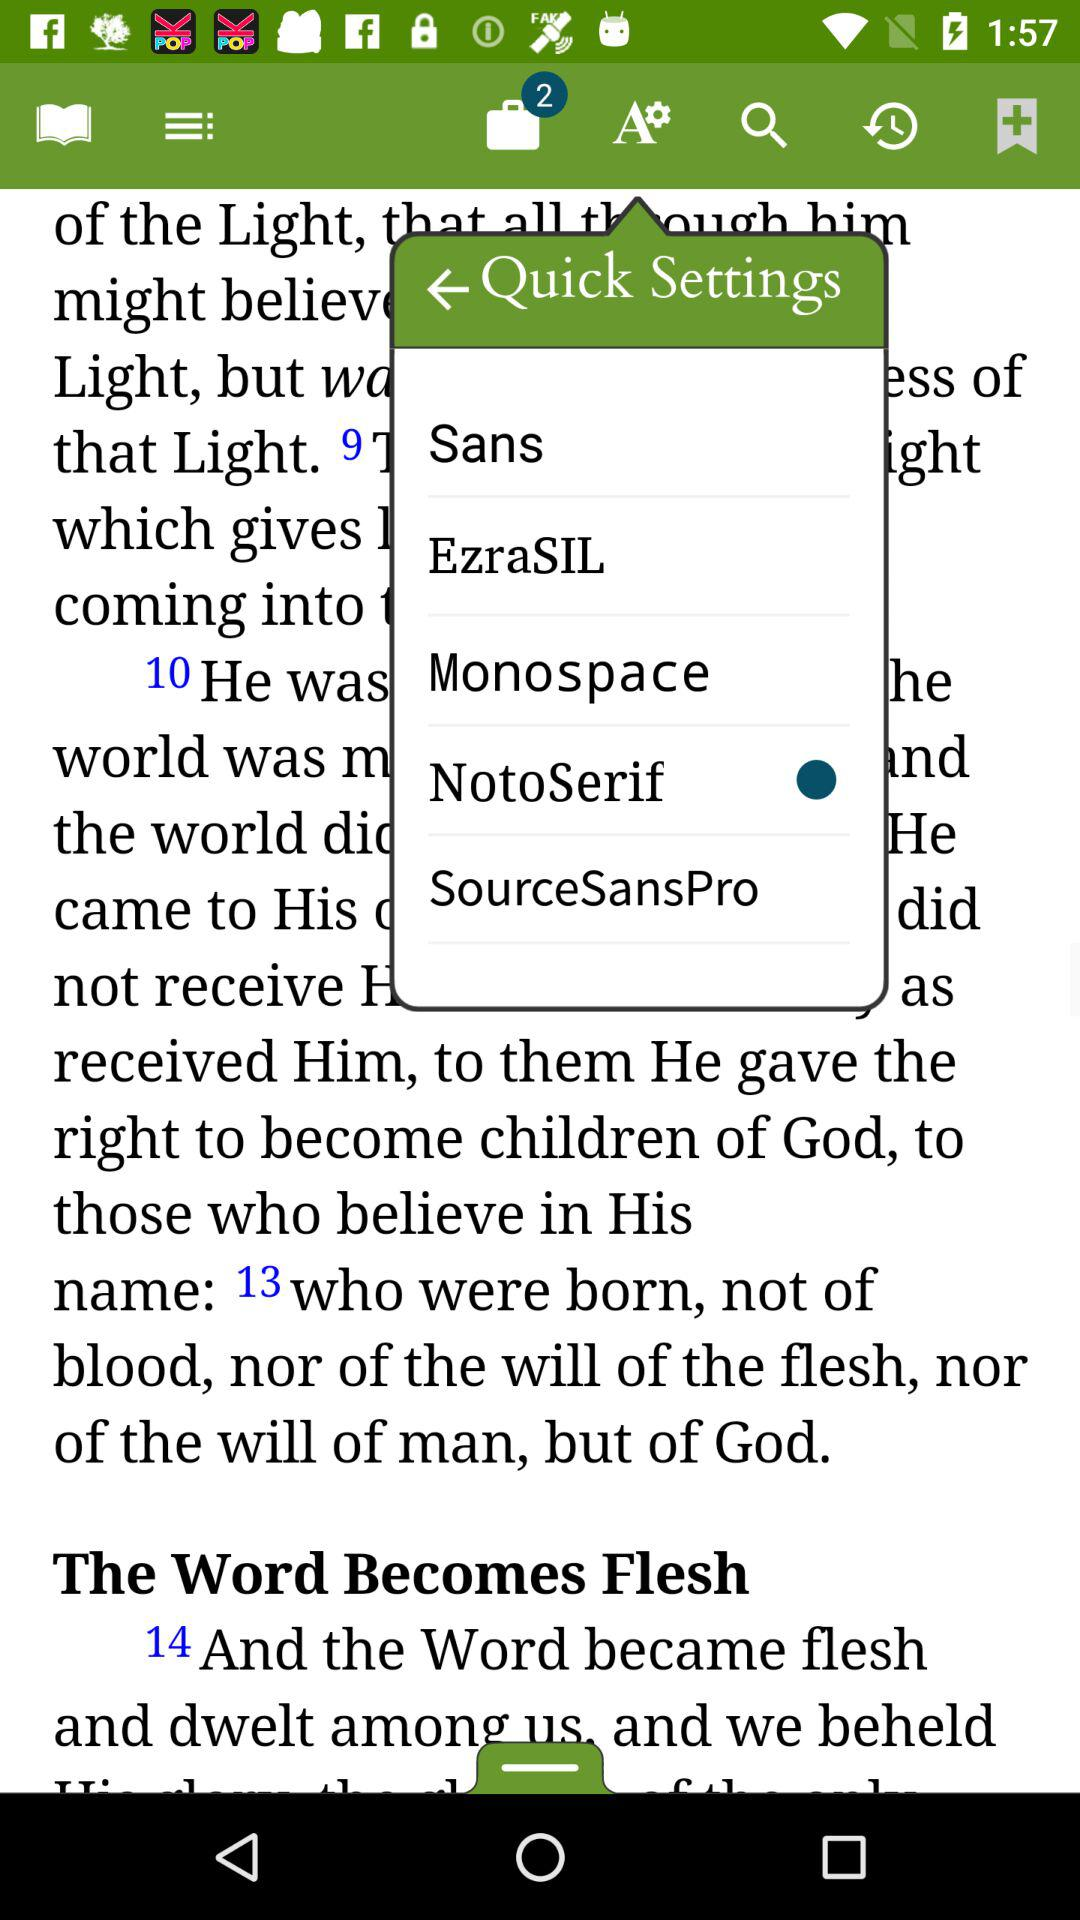Which option is selected in "Quick Settings"? The selected option is "NotoSerif". 